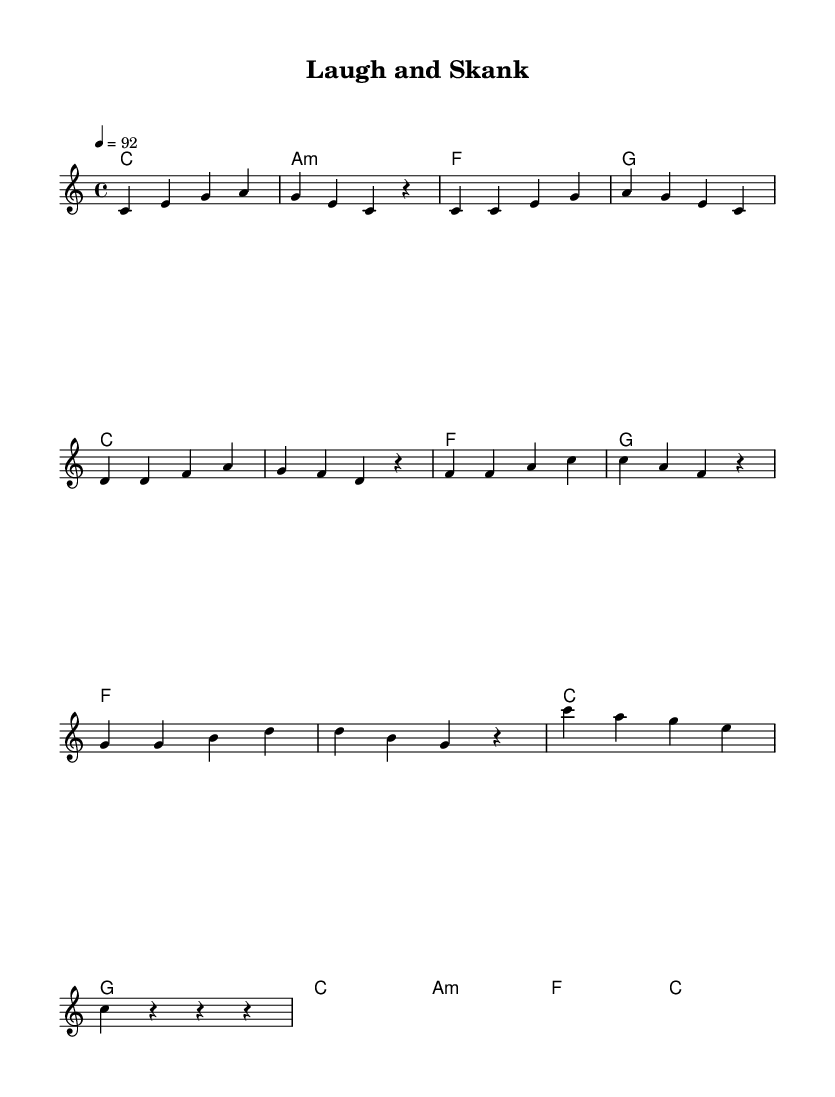What is the key signature of this music? The key signature indicated in the score is C major, which is shown as having no sharps or flats. This can be confirmed by observing the key signature at the beginning of the piece.
Answer: C major What is the time signature of this music? The time signature shown in the music is 4/4, which means there are four beats in each measure and the quarter note receives one beat. This is identifiable at the start of the piece.
Answer: 4/4 What is the tempo of this piece? The tempo marking indicates a speed of quarter note equals 92 beats per minute. This is found at the top of the score, specifying how fast the piece should be played.
Answer: 92 How many measures are there in the chorus? The chorus consists of 4 measures, as seen by counting the distinct sets of music notation that appear in the chorus section labeled in the score.
Answer: 4 What is the ending chord of the music? The ending chord, as indicated in the outro section, is C major. The last chord symbol in the harmonies corresponds directly to this ending.
Answer: C Which section contains the melody line labeled as "melody"? The melody line labeled as "melody" is found in the new Voice section within the score, indicating that this part is specifically designated for the main melodic component.
Answer: melody What type of music style is this piece? This piece is specifically categorized as reggae, identifiable by its rhythmic patterns and melodic style that align with traditional reggae music characteristics.
Answer: reggae 